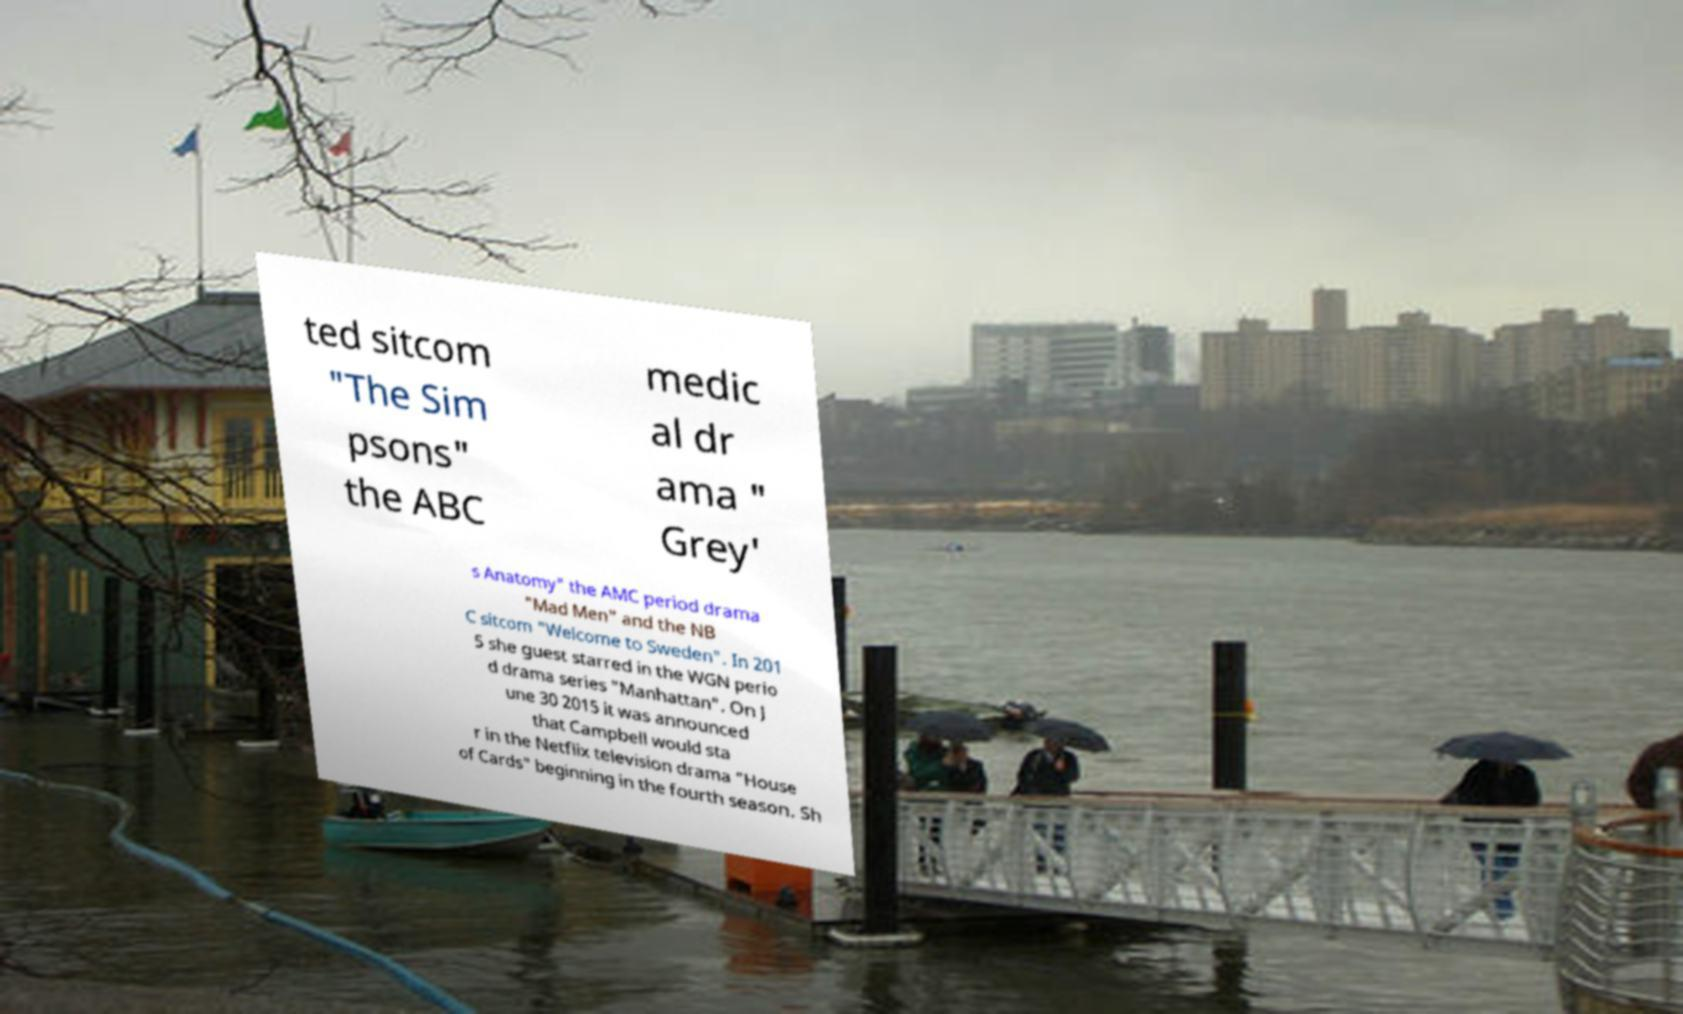There's text embedded in this image that I need extracted. Can you transcribe it verbatim? ted sitcom "The Sim psons" the ABC medic al dr ama " Grey' s Anatomy" the AMC period drama "Mad Men" and the NB C sitcom "Welcome to Sweden". In 201 5 she guest starred in the WGN perio d drama series "Manhattan". On J une 30 2015 it was announced that Campbell would sta r in the Netflix television drama "House of Cards" beginning in the fourth season. Sh 